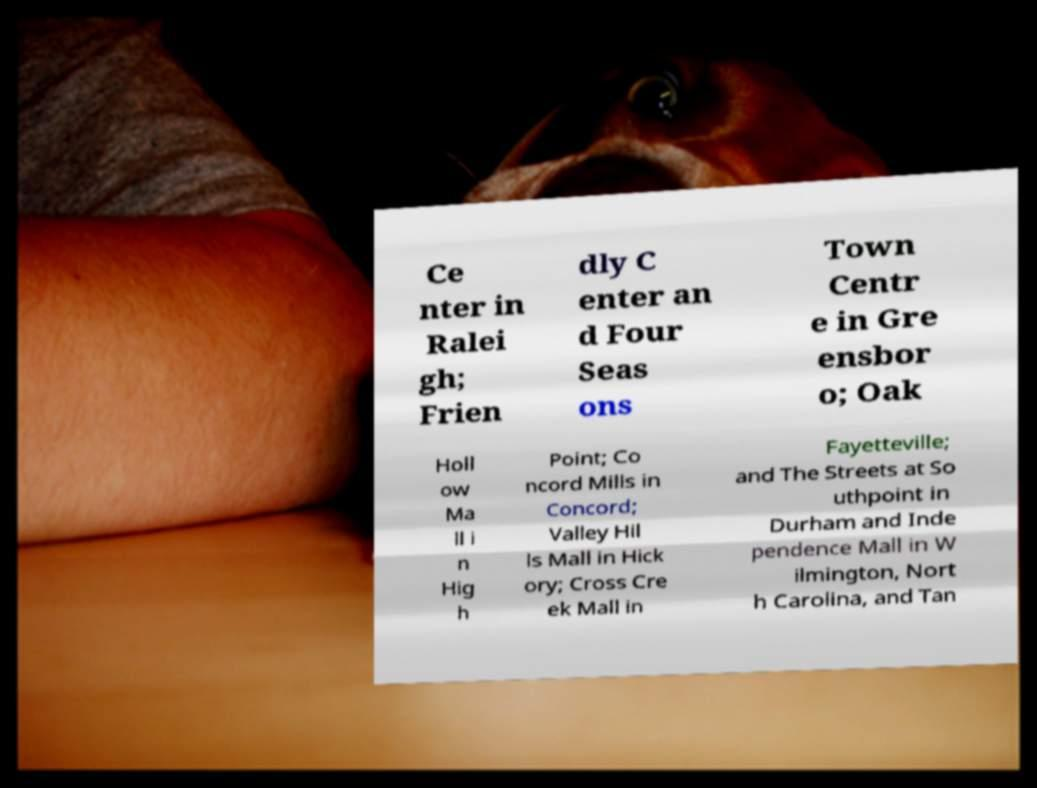I need the written content from this picture converted into text. Can you do that? Ce nter in Ralei gh; Frien dly C enter an d Four Seas ons Town Centr e in Gre ensbor o; Oak Holl ow Ma ll i n Hig h Point; Co ncord Mills in Concord; Valley Hil ls Mall in Hick ory; Cross Cre ek Mall in Fayetteville; and The Streets at So uthpoint in Durham and Inde pendence Mall in W ilmington, Nort h Carolina, and Tan 